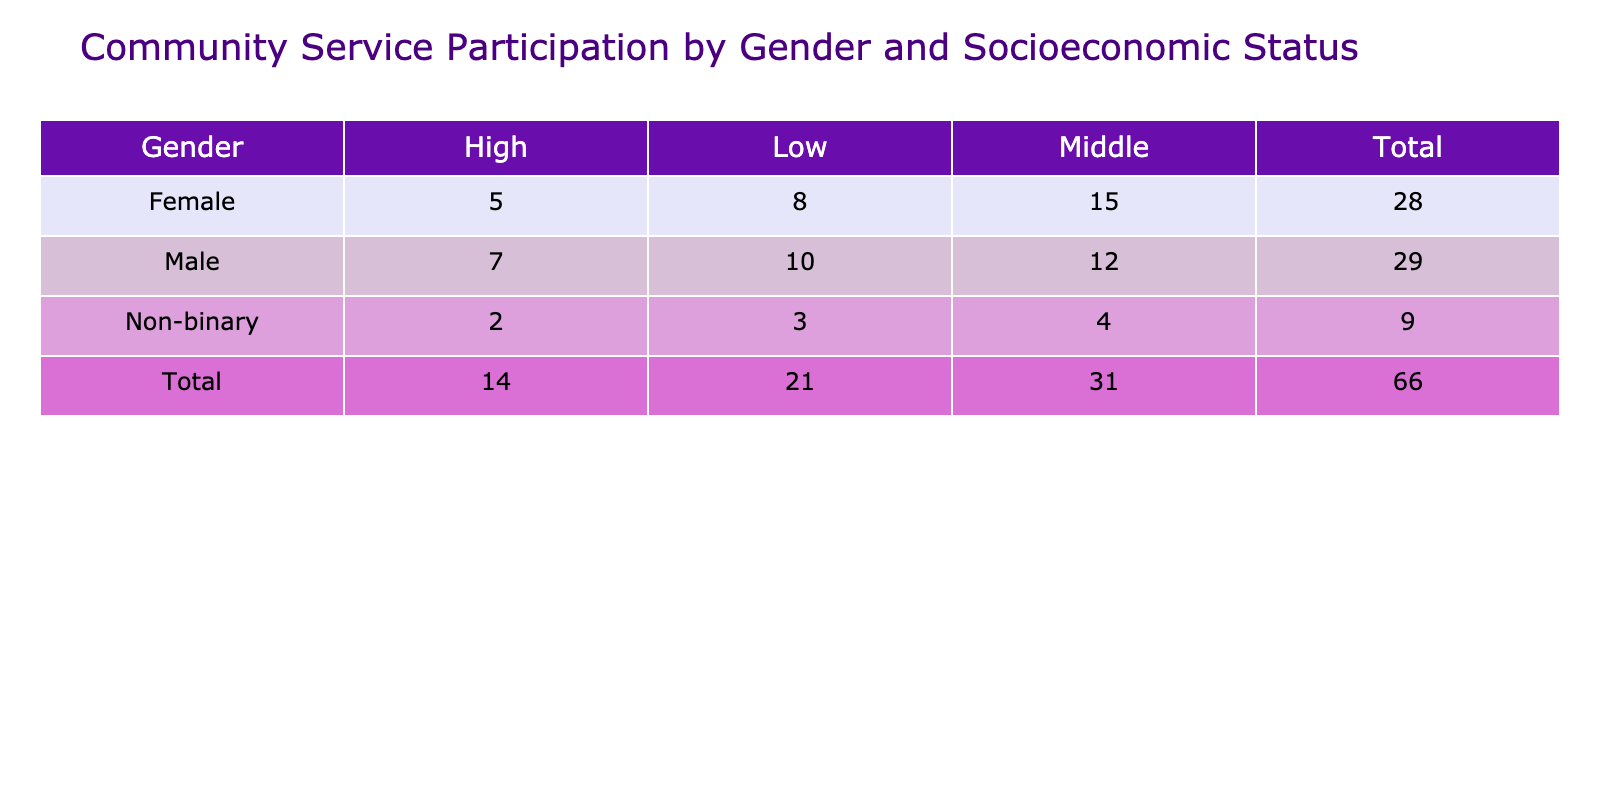What is the total frequency of community service participation for females? The table shows the frequency of participation by gender. To find the total for females, I look at the row for "Female" and sum the frequencies: 8 (Low) + 15 (Middle) + 5 (High) = 28.
Answer: 28 How many males participate in community service at a high socioeconomic status? In the table, I locate the row for "Male" and the column for "High" to find the value, which is 7.
Answer: 7 Is there a higher frequency of community service participation among low socioeconomic status individuals compared to those of middle socioeconomic status? I check the total frequencies for low and middle socioeconomic status. The values for Low are: Female (8) + Male (10) + Non-binary (3) = 21. For Middle: Female (15) + Male (12) + Non-binary (4) = 31. Since 21 is less than 31, the statement is false.
Answer: No What is the average frequency of participation for non-binary individuals across all socioeconomic statuses? The frequencies for non-binary are 3 (Low), 4 (Middle), and 2 (High). To find the average, I calculate the sum: 3 + 4 + 2 = 9, then divide by the number of participation instances which is 3: 9 / 3 = 3.
Answer: 3 How does the total frequency of participation for middle socioeconomic status compare to that for low socioeconomic status? First, I sum the frequencies for middle: Female (15) + Male (12) + Non-binary (4) = 31. Then, I sum for low: Female (8) + Male (10) + Non-binary (3) = 21. The comparison shows 31 (middle) is greater than 21 (low), confirming that middle has higher participation.
Answer: Middle has higher participation 